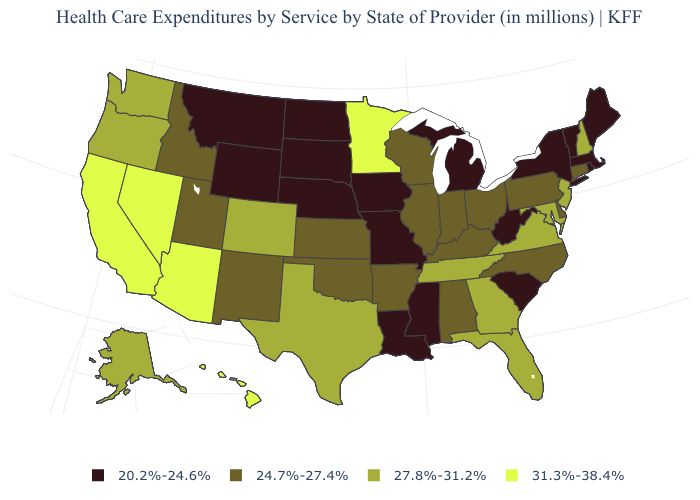What is the value of Oklahoma?
Give a very brief answer. 24.7%-27.4%. What is the value of Arizona?
Write a very short answer. 31.3%-38.4%. Does Oregon have the same value as Colorado?
Answer briefly. Yes. Does Connecticut have the same value as Maine?
Write a very short answer. No. Does the map have missing data?
Be succinct. No. What is the lowest value in the USA?
Write a very short answer. 20.2%-24.6%. What is the lowest value in the Northeast?
Quick response, please. 20.2%-24.6%. What is the value of Utah?
Short answer required. 24.7%-27.4%. Name the states that have a value in the range 27.8%-31.2%?
Quick response, please. Alaska, Colorado, Florida, Georgia, Maryland, New Hampshire, New Jersey, Oregon, Tennessee, Texas, Virginia, Washington. Name the states that have a value in the range 27.8%-31.2%?
Write a very short answer. Alaska, Colorado, Florida, Georgia, Maryland, New Hampshire, New Jersey, Oregon, Tennessee, Texas, Virginia, Washington. Name the states that have a value in the range 31.3%-38.4%?
Concise answer only. Arizona, California, Hawaii, Minnesota, Nevada. What is the lowest value in the USA?
Answer briefly. 20.2%-24.6%. Name the states that have a value in the range 24.7%-27.4%?
Quick response, please. Alabama, Arkansas, Connecticut, Delaware, Idaho, Illinois, Indiana, Kansas, Kentucky, New Mexico, North Carolina, Ohio, Oklahoma, Pennsylvania, Utah, Wisconsin. Among the states that border Utah , does Wyoming have the lowest value?
Answer briefly. Yes. What is the value of Kansas?
Concise answer only. 24.7%-27.4%. 